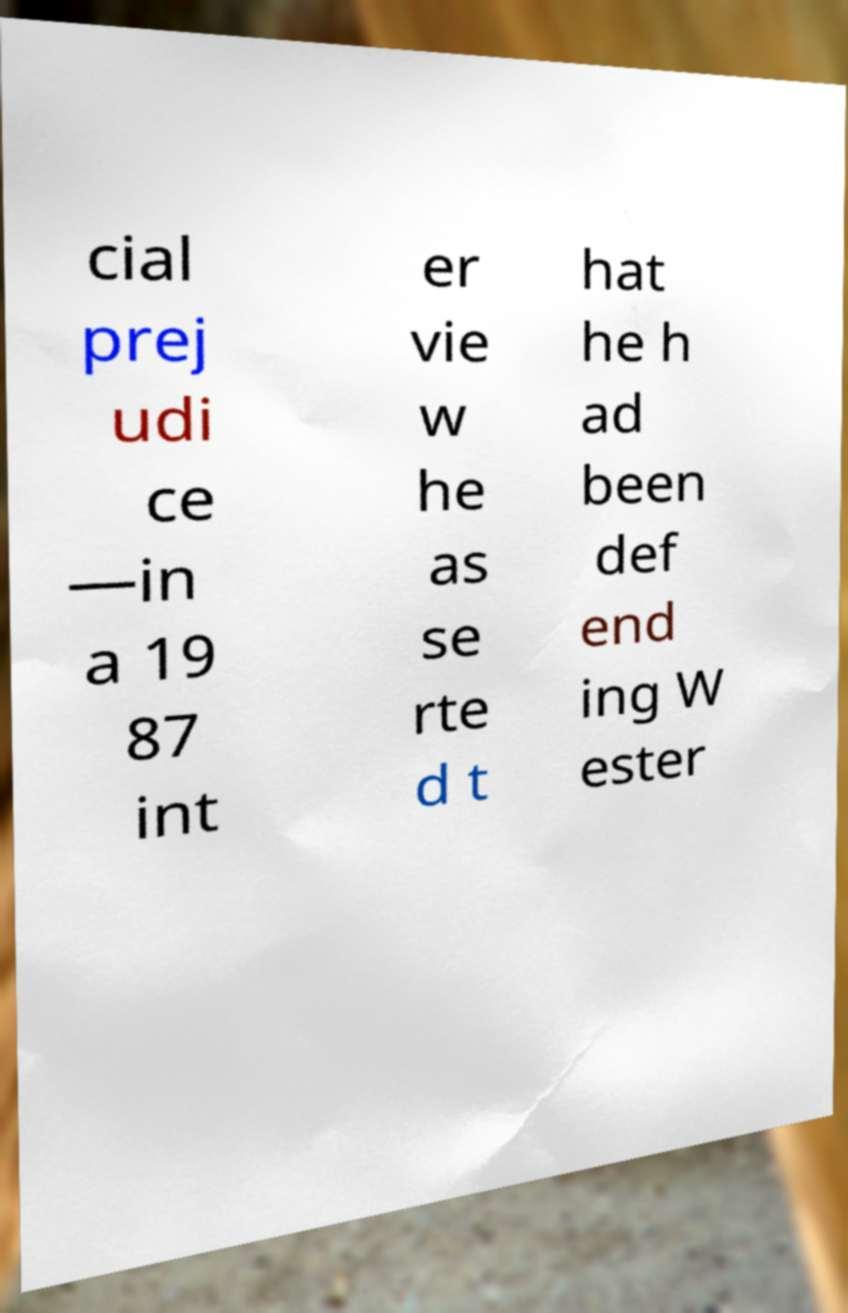For documentation purposes, I need the text within this image transcribed. Could you provide that? cial prej udi ce —in a 19 87 int er vie w he as se rte d t hat he h ad been def end ing W ester 